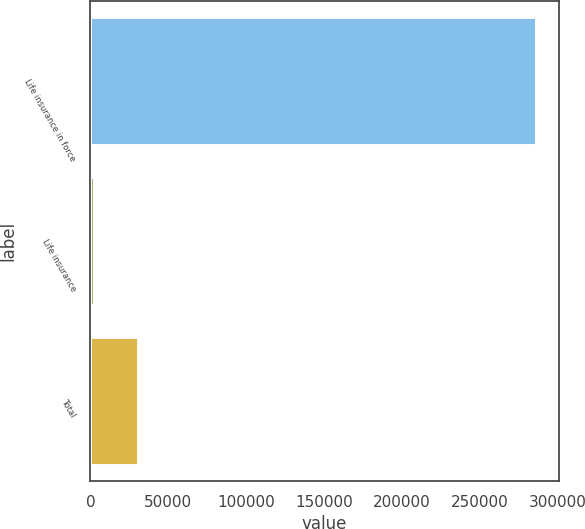<chart> <loc_0><loc_0><loc_500><loc_500><bar_chart><fcel>Life insurance in force<fcel>Life insurance<fcel>Total<nl><fcel>286435<fcel>2289.4<fcel>30704<nl></chart> 